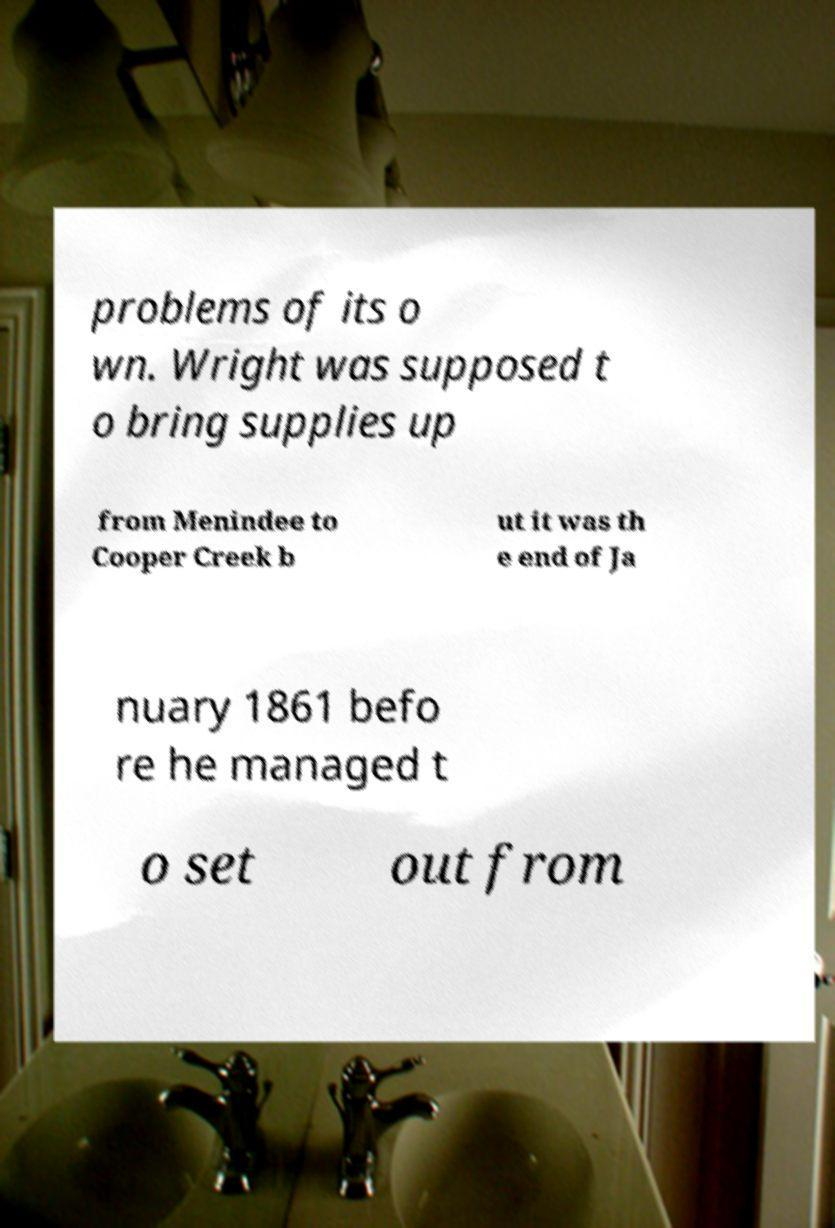What messages or text are displayed in this image? I need them in a readable, typed format. problems of its o wn. Wright was supposed t o bring supplies up from Menindee to Cooper Creek b ut it was th e end of Ja nuary 1861 befo re he managed t o set out from 